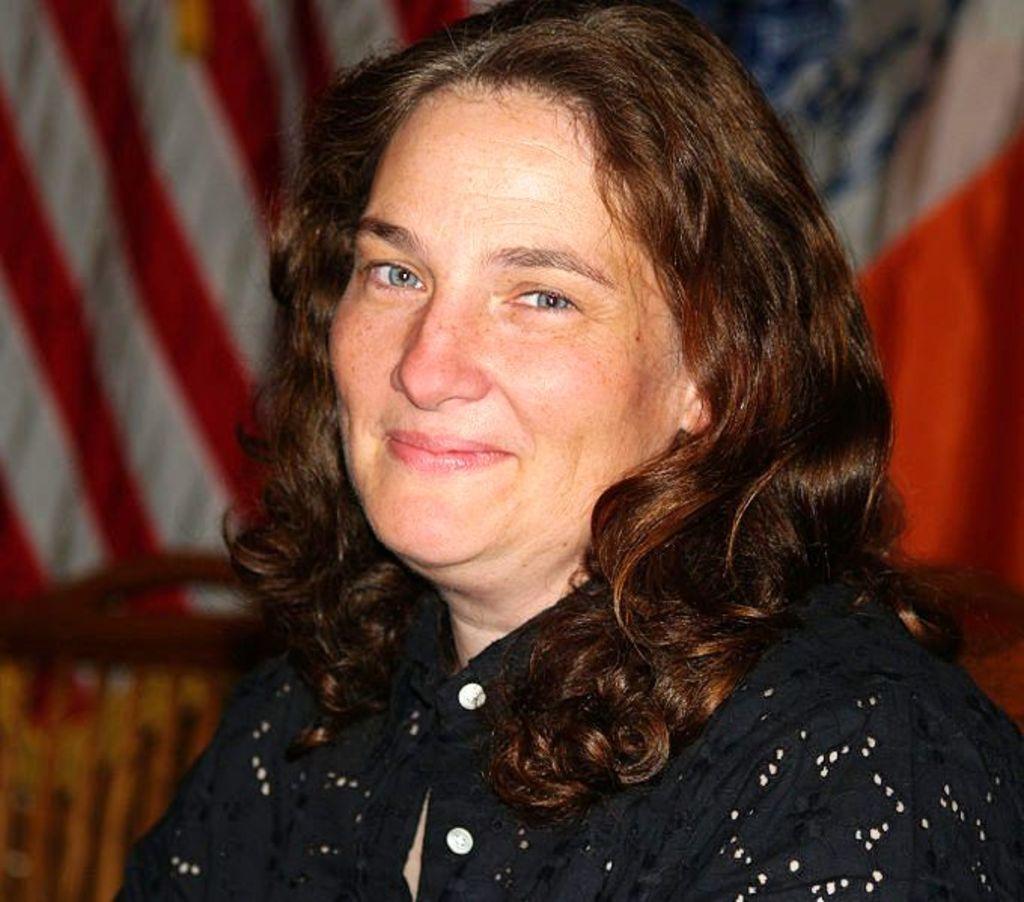In one or two sentences, can you explain what this image depicts? In this picture, we can see a woman wearing a black color dress. In the background, we can see some flags. 